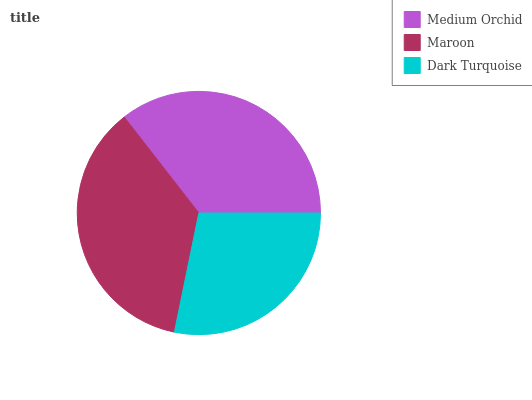Is Dark Turquoise the minimum?
Answer yes or no. Yes. Is Maroon the maximum?
Answer yes or no. Yes. Is Maroon the minimum?
Answer yes or no. No. Is Dark Turquoise the maximum?
Answer yes or no. No. Is Maroon greater than Dark Turquoise?
Answer yes or no. Yes. Is Dark Turquoise less than Maroon?
Answer yes or no. Yes. Is Dark Turquoise greater than Maroon?
Answer yes or no. No. Is Maroon less than Dark Turquoise?
Answer yes or no. No. Is Medium Orchid the high median?
Answer yes or no. Yes. Is Medium Orchid the low median?
Answer yes or no. Yes. Is Maroon the high median?
Answer yes or no. No. Is Maroon the low median?
Answer yes or no. No. 